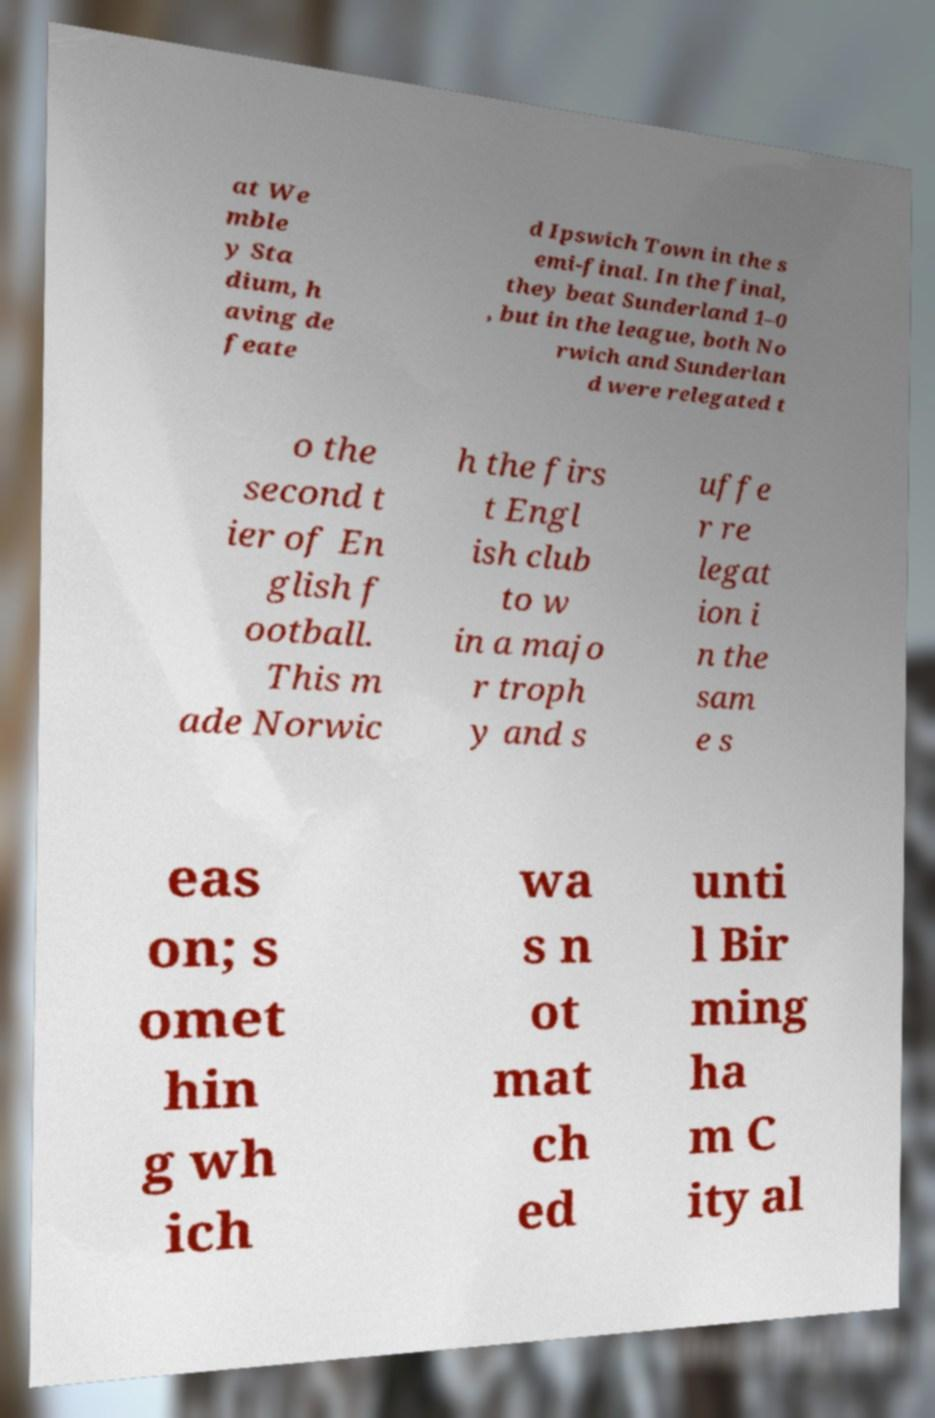Can you accurately transcribe the text from the provided image for me? at We mble y Sta dium, h aving de feate d Ipswich Town in the s emi-final. In the final, they beat Sunderland 1–0 , but in the league, both No rwich and Sunderlan d were relegated t o the second t ier of En glish f ootball. This m ade Norwic h the firs t Engl ish club to w in a majo r troph y and s uffe r re legat ion i n the sam e s eas on; s omet hin g wh ich wa s n ot mat ch ed unti l Bir ming ha m C ity al 